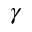<formula> <loc_0><loc_0><loc_500><loc_500>\gamma</formula> 